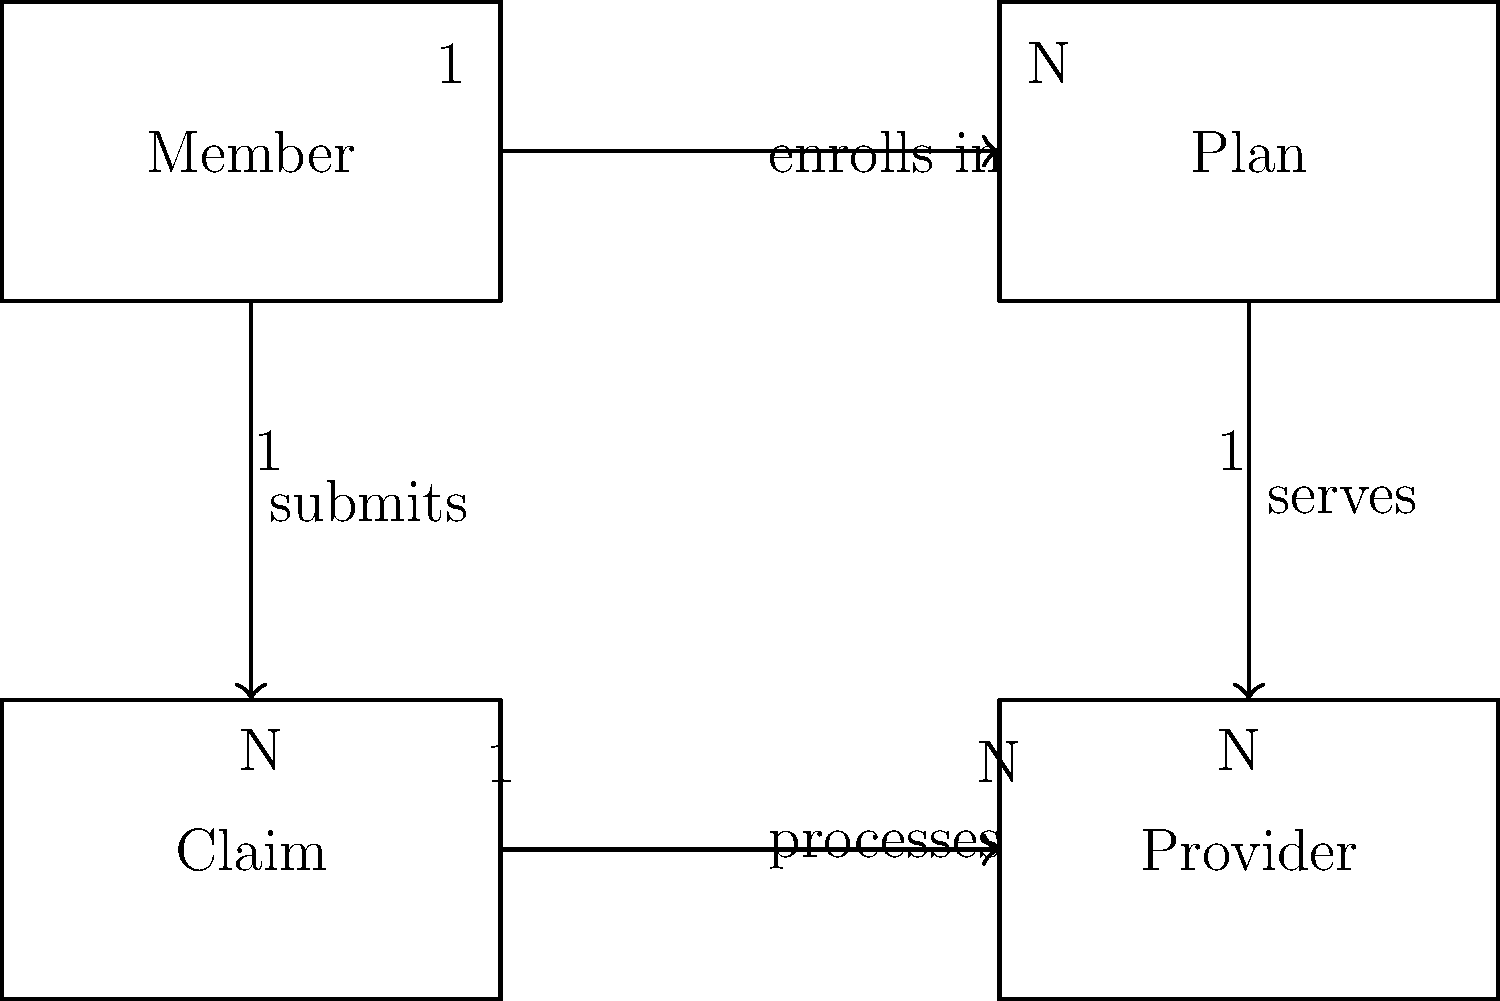In the entity-relationship diagram for a health plan's member database, what is the relationship between the Member entity and the Plan entity? To determine the relationship between the Member entity and the Plan entity, we need to analyze the diagram step-by-step:

1. Locate the Member and Plan entities in the diagram.
2. Observe the connecting line between these two entities.
3. Note the direction of the arrow, which goes from Member to Plan.
4. Read the label on the connecting line, which states "enrolls in".
5. Examine the cardinality notation:
   - Near the Member entity, we see "1", indicating that one member
   - Near the Plan entity, we see "N", indicating many plans

This information tells us that:
- A member can enroll in many plans (1:N relationship)
- A plan can have many members (N:1 relationship)

Therefore, the overall relationship between Member and Plan is many-to-many (M:N), as a member can enroll in multiple plans, and a plan can have multiple members.
Answer: Many-to-many (M:N) 